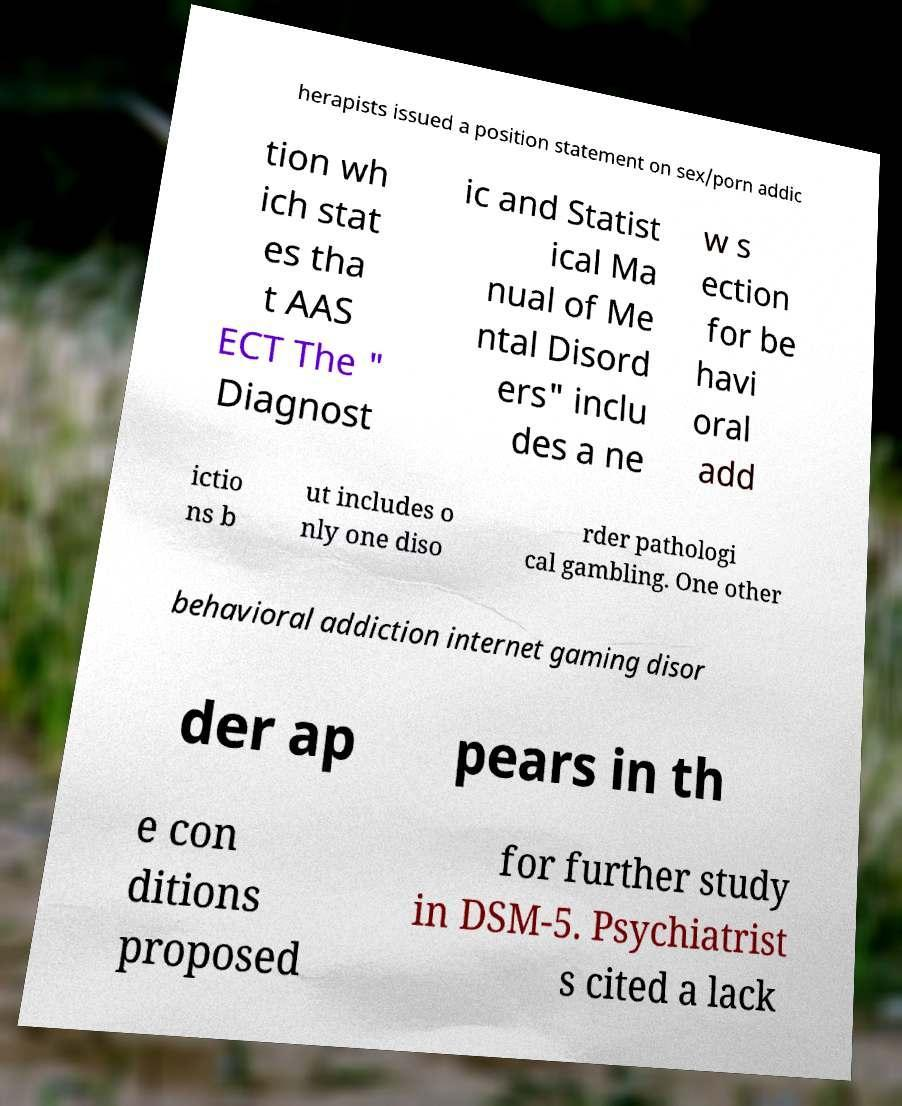Can you accurately transcribe the text from the provided image for me? herapists issued a position statement on sex/porn addic tion wh ich stat es tha t AAS ECT The " Diagnost ic and Statist ical Ma nual of Me ntal Disord ers" inclu des a ne w s ection for be havi oral add ictio ns b ut includes o nly one diso rder pathologi cal gambling. One other behavioral addiction internet gaming disor der ap pears in th e con ditions proposed for further study in DSM-5. Psychiatrist s cited a lack 